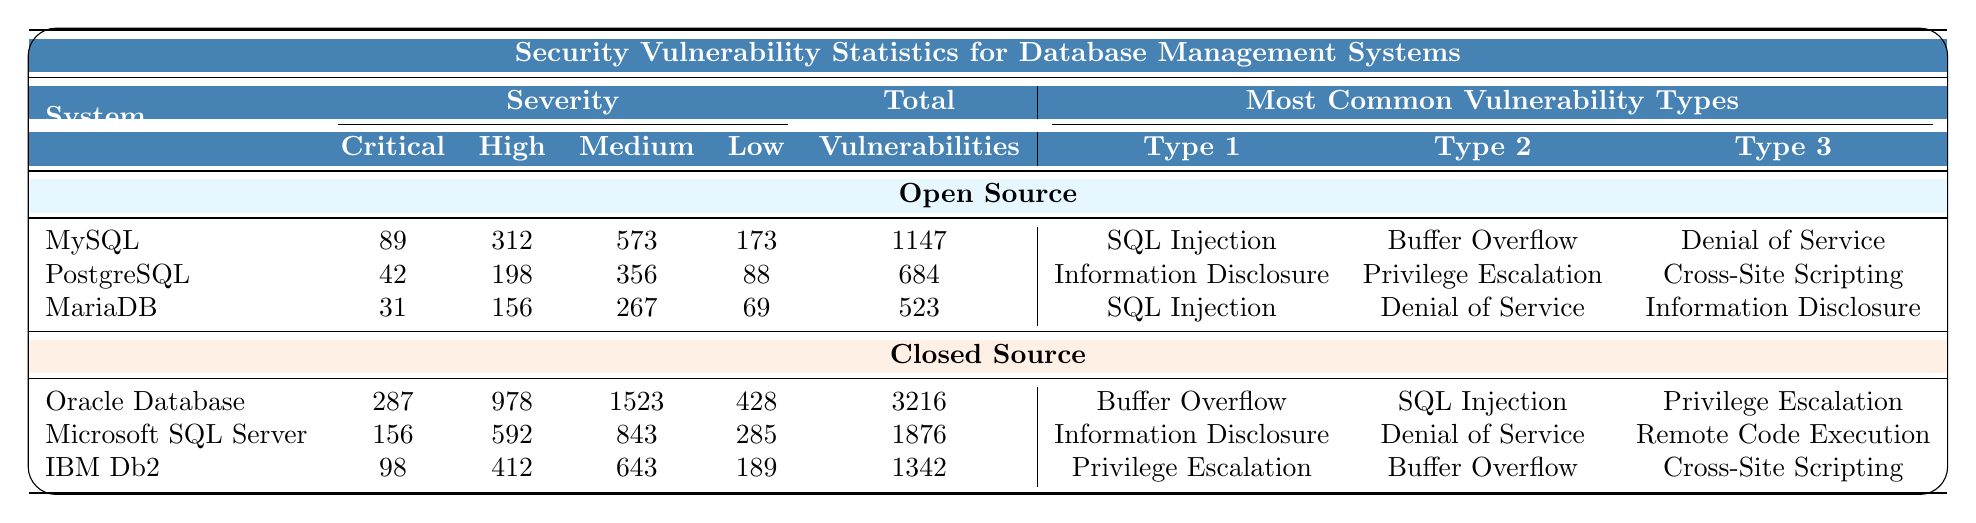What is the total number of vulnerabilities for MySQL? The table shows that the total number of vulnerabilities for MySQL is specified in the "Total" column, which is listed as 1147.
Answer: 1147 How many critical vulnerabilities does PostgreSQL have? According to the table, PostgreSQL has 42 critical vulnerabilities as indicated in the "Critical" column.
Answer: 42 Which closed source system has the highest number of total vulnerabilities? By reviewing the "Total" column for closed source systems, Oracle Database has the highest total with 3216 vulnerabilities.
Answer: Oracle Database What is the difference between the total vulnerabilities of Oracle Database and Microsoft SQL Server? Oracle Database has 3216 vulnerabilities and Microsoft SQL Server has 1876 vulnerabilities. The difference is calculated as 3216 - 1876 = 1340.
Answer: 1340 Combine the critical vulnerabilities of all open source systems. The critical vulnerabilities for MySQL (89), PostgreSQL (42), and MariaDB (31) add up as follows: 89 + 42 + 31 = 162.
Answer: 162 Is Information Disclosure listed as a common vulnerability type for both open source and closed source systems? The table indicates that Information Disclosure is a common vulnerability type for PostgreSQL (open source) and also for Microsoft SQL Server (closed source), confirming that it is present in both categories.
Answer: Yes What is the average number of high vulnerabilities for open source systems? To calculate the average for high vulnerabilities, sum those for MySQL (312), PostgreSQL (198), and MariaDB (156), which is 312 + 198 + 156 = 666. There are 3 systems, so the average is 666 / 3 = 222.
Answer: 222 Which system has the highest count of low vulnerabilities, and how many are there? The table shows that Oracle Database has 428 low vulnerabilities, the highest among all; this can be confirmed by comparing the values in the "Low" column.
Answer: Oracle Database, 428 How many total vulnerabilities do all open source systems have combined? The total vulnerabilities for open source systems are the sum of those listed: MySQL has 1147, PostgreSQL has 684, and MariaDB has 523, which adds up to 1147 + 684 + 523 = 2354.
Answer: 2354 Which closed source system has a higher number of medium vulnerabilities, Oracle Database or IBM Db2? Oracle Database has 1523 medium vulnerabilities and IBM Db2 has 643. Comparing these values confirms that Oracle Database has a significantly higher count.
Answer: Oracle Database 